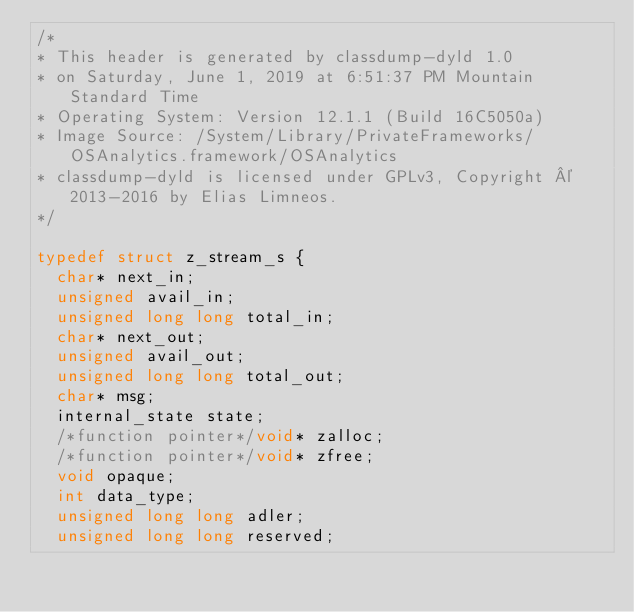<code> <loc_0><loc_0><loc_500><loc_500><_C_>/*
* This header is generated by classdump-dyld 1.0
* on Saturday, June 1, 2019 at 6:51:37 PM Mountain Standard Time
* Operating System: Version 12.1.1 (Build 16C5050a)
* Image Source: /System/Library/PrivateFrameworks/OSAnalytics.framework/OSAnalytics
* classdump-dyld is licensed under GPLv3, Copyright © 2013-2016 by Elias Limneos.
*/

typedef struct z_stream_s {
	char* next_in;
	unsigned avail_in;
	unsigned long long total_in;
	char* next_out;
	unsigned avail_out;
	unsigned long long total_out;
	char* msg;
	internal_state state;
	/*function pointer*/void* zalloc;
	/*function pointer*/void* zfree;
	void opaque;
	int data_type;
	unsigned long long adler;
	unsigned long long reserved;</code> 